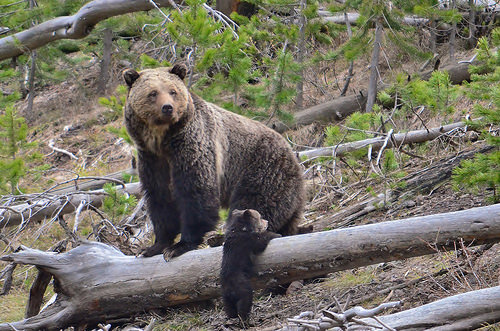<image>
Is there a bear to the right of the log? No. The bear is not to the right of the log. The horizontal positioning shows a different relationship. Is there a cub in front of the adult bear? Yes. The cub is positioned in front of the adult bear, appearing closer to the camera viewpoint. 